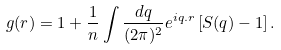Convert formula to latex. <formula><loc_0><loc_0><loc_500><loc_500>g ( r ) = 1 + \frac { 1 } { n } \int \frac { d q } { ( 2 \pi ) ^ { 2 } } e ^ { i { q } . { r } } \left [ S ( q ) - 1 \right ] .</formula> 